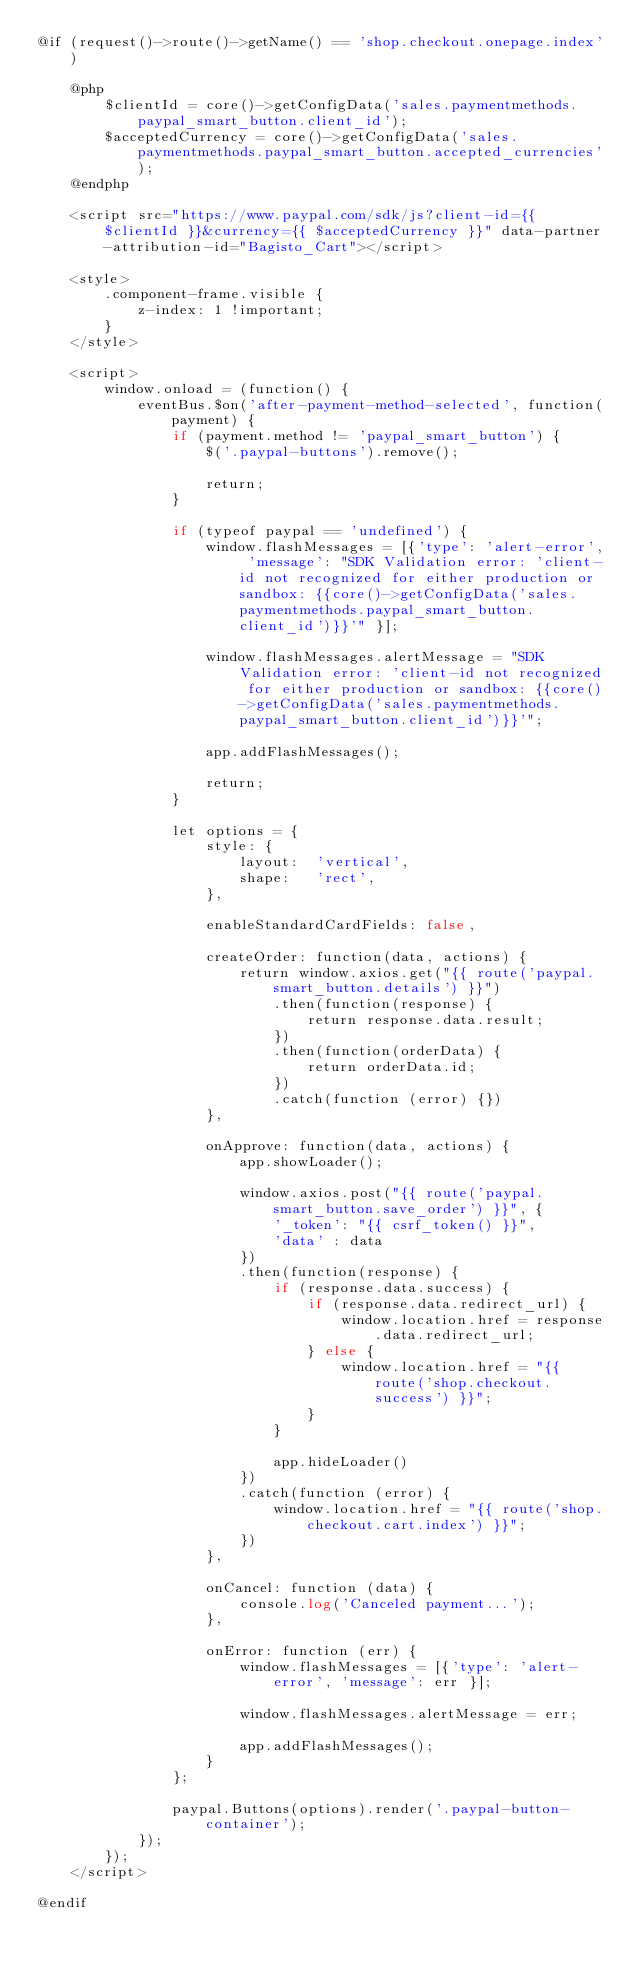<code> <loc_0><loc_0><loc_500><loc_500><_PHP_>@if (request()->route()->getName() == 'shop.checkout.onepage.index')

    @php
        $clientId = core()->getConfigData('sales.paymentmethods.paypal_smart_button.client_id');
        $acceptedCurrency = core()->getConfigData('sales.paymentmethods.paypal_smart_button.accepted_currencies');
    @endphp

    <script src="https://www.paypal.com/sdk/js?client-id={{ $clientId }}&currency={{ $acceptedCurrency }}" data-partner-attribution-id="Bagisto_Cart"></script>

    <style>
        .component-frame.visible {
            z-index: 1 !important;
        }
    </style>

    <script>
        window.onload = (function() {
            eventBus.$on('after-payment-method-selected', function(payment) {
                if (payment.method != 'paypal_smart_button') {
                    $('.paypal-buttons').remove();

                    return;
                }

                if (typeof paypal == 'undefined') {
                    window.flashMessages = [{'type': 'alert-error', 'message': "SDK Validation error: 'client-id not recognized for either production or sandbox: {{core()->getConfigData('sales.paymentmethods.paypal_smart_button.client_id')}}'" }];

                    window.flashMessages.alertMessage = "SDK Validation error: 'client-id not recognized for either production or sandbox: {{core()->getConfigData('sales.paymentmethods.paypal_smart_button.client_id')}}'";

                    app.addFlashMessages();

                    return;
                }

                let options = {
                    style: {
                        layout:  'vertical',
                        shape:   'rect',
                    },

                    enableStandardCardFields: false,

                    createOrder: function(data, actions) {
                        return window.axios.get("{{ route('paypal.smart_button.details') }}")
                            .then(function(response) {
                                return response.data.result;
                            })
                            .then(function(orderData) {
                                return orderData.id;
                            })
                            .catch(function (error) {})
                    },

                    onApprove: function(data, actions) {
                        app.showLoader();

                        window.axios.post("{{ route('paypal.smart_button.save_order') }}", {
                            '_token': "{{ csrf_token() }}",
                            'data' : data
                        })
                        .then(function(response) {
                            if (response.data.success) {
                                if (response.data.redirect_url) {
                                    window.location.href = response.data.redirect_url;
                                } else {
                                    window.location.href = "{{ route('shop.checkout.success') }}";
                                }
                            }

                            app.hideLoader()
                        })
                        .catch(function (error) {
                            window.location.href = "{{ route('shop.checkout.cart.index') }}";
                        })
                    },

                    onCancel: function (data) {
                        console.log('Canceled payment...');
                    },

                    onError: function (err) {
                        window.flashMessages = [{'type': 'alert-error', 'message': err }];

                        window.flashMessages.alertMessage = err;

                        app.addFlashMessages();
                    }
                };

                paypal.Buttons(options).render('.paypal-button-container');
            });
        });
    </script>

@endif</code> 